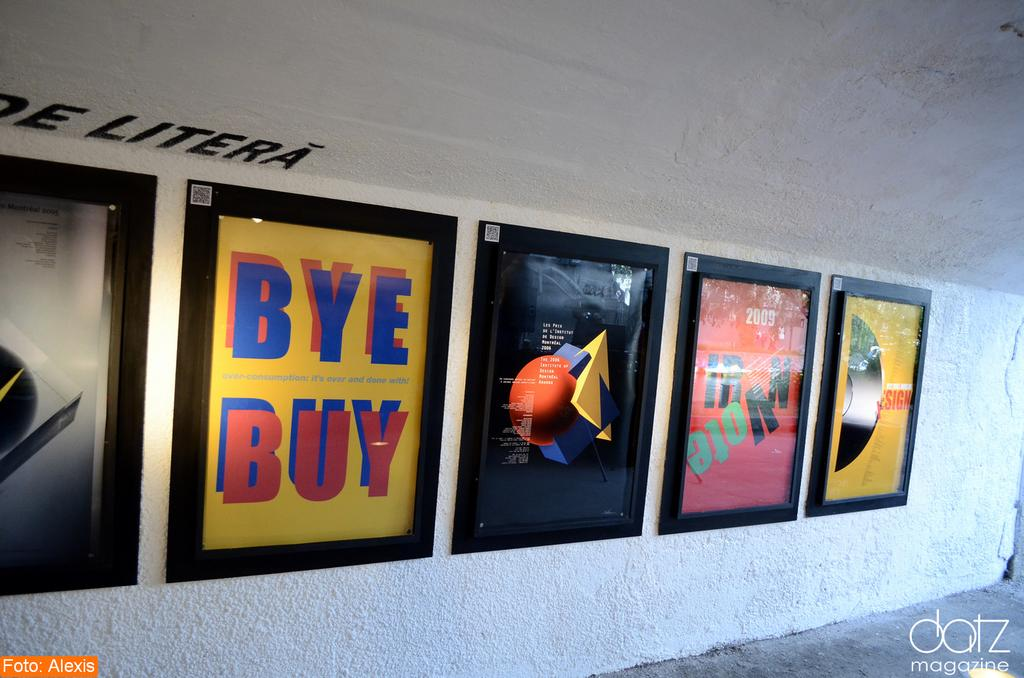<image>
Relay a brief, clear account of the picture shown. Several framed posters sit neatly in a row, one with the words BYE BUY on it. 